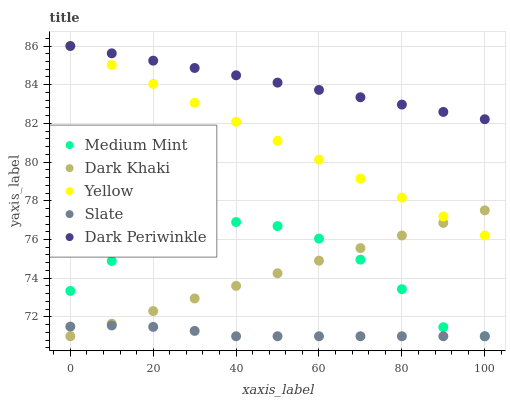Does Slate have the minimum area under the curve?
Answer yes or no. Yes. Does Dark Periwinkle have the maximum area under the curve?
Answer yes or no. Yes. Does Dark Khaki have the minimum area under the curve?
Answer yes or no. No. Does Dark Khaki have the maximum area under the curve?
Answer yes or no. No. Is Dark Khaki the smoothest?
Answer yes or no. Yes. Is Medium Mint the roughest?
Answer yes or no. Yes. Is Slate the smoothest?
Answer yes or no. No. Is Slate the roughest?
Answer yes or no. No. Does Medium Mint have the lowest value?
Answer yes or no. Yes. Does Dark Periwinkle have the lowest value?
Answer yes or no. No. Does Yellow have the highest value?
Answer yes or no. Yes. Does Dark Khaki have the highest value?
Answer yes or no. No. Is Dark Khaki less than Dark Periwinkle?
Answer yes or no. Yes. Is Yellow greater than Medium Mint?
Answer yes or no. Yes. Does Slate intersect Medium Mint?
Answer yes or no. Yes. Is Slate less than Medium Mint?
Answer yes or no. No. Is Slate greater than Medium Mint?
Answer yes or no. No. Does Dark Khaki intersect Dark Periwinkle?
Answer yes or no. No. 